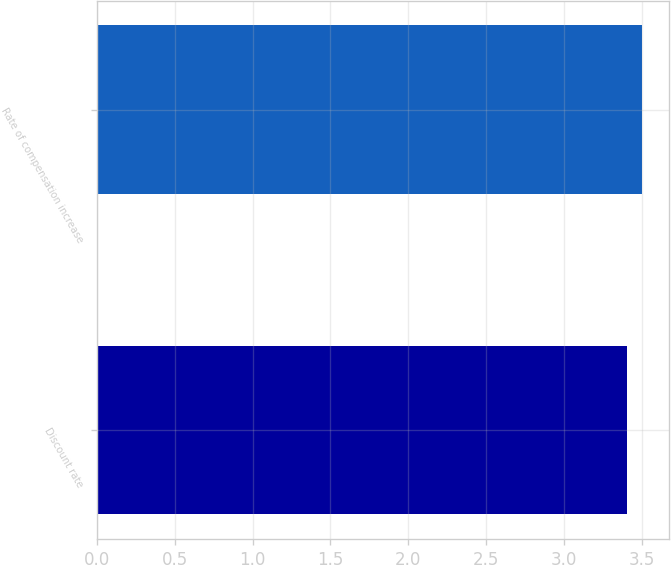Convert chart. <chart><loc_0><loc_0><loc_500><loc_500><bar_chart><fcel>Discount rate<fcel>Rate of compensation increase<nl><fcel>3.4<fcel>3.5<nl></chart> 